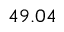<formula> <loc_0><loc_0><loc_500><loc_500>4 9 . 0 4</formula> 